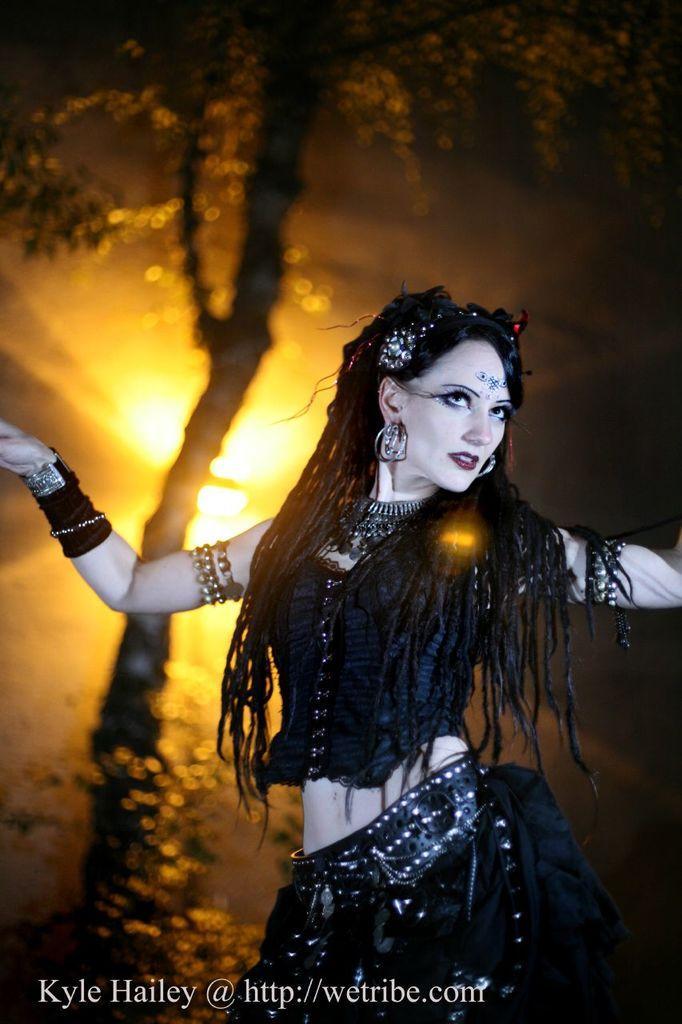Please provide a concise description of this image. In this picture we can see a woman. There is some text at the bottom. We can see a tree and lights in the background. 